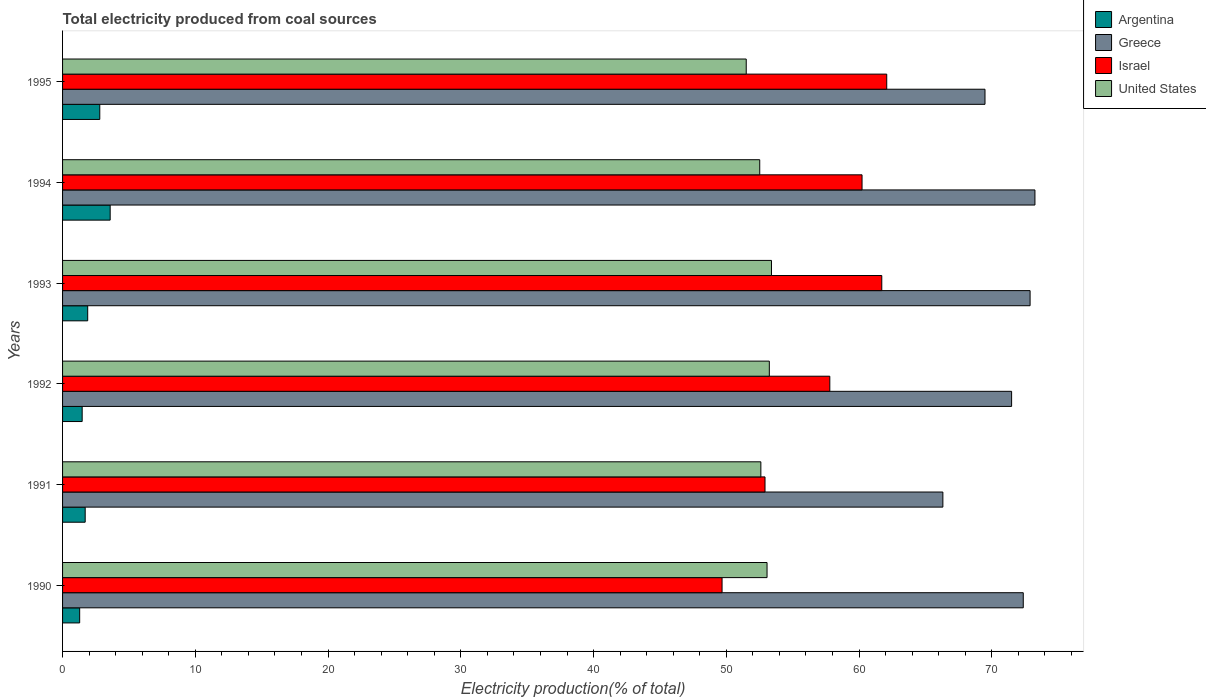How many different coloured bars are there?
Keep it short and to the point. 4. How many groups of bars are there?
Give a very brief answer. 6. Are the number of bars on each tick of the Y-axis equal?
Ensure brevity in your answer.  Yes. How many bars are there on the 2nd tick from the top?
Offer a very short reply. 4. What is the total electricity produced in United States in 1992?
Your response must be concise. 53.24. Across all years, what is the maximum total electricity produced in Argentina?
Make the answer very short. 3.59. Across all years, what is the minimum total electricity produced in United States?
Provide a succinct answer. 51.5. In which year was the total electricity produced in Israel maximum?
Keep it short and to the point. 1995. In which year was the total electricity produced in Israel minimum?
Provide a short and direct response. 1990. What is the total total electricity produced in Israel in the graph?
Give a very brief answer. 344.41. What is the difference between the total electricity produced in Israel in 1990 and that in 1992?
Offer a terse response. -8.12. What is the difference between the total electricity produced in United States in 1990 and the total electricity produced in Greece in 1992?
Ensure brevity in your answer.  -18.42. What is the average total electricity produced in Argentina per year?
Keep it short and to the point. 2.13. In the year 1993, what is the difference between the total electricity produced in Argentina and total electricity produced in Greece?
Keep it short and to the point. -70.99. What is the ratio of the total electricity produced in Argentina in 1990 to that in 1995?
Provide a succinct answer. 0.46. Is the total electricity produced in Argentina in 1992 less than that in 1995?
Keep it short and to the point. Yes. What is the difference between the highest and the second highest total electricity produced in Israel?
Offer a terse response. 0.37. What is the difference between the highest and the lowest total electricity produced in Argentina?
Keep it short and to the point. 2.3. Is the sum of the total electricity produced in United States in 1990 and 1991 greater than the maximum total electricity produced in Greece across all years?
Your response must be concise. Yes. What does the 4th bar from the top in 1991 represents?
Offer a very short reply. Argentina. What does the 1st bar from the bottom in 1991 represents?
Keep it short and to the point. Argentina. Is it the case that in every year, the sum of the total electricity produced in Argentina and total electricity produced in Israel is greater than the total electricity produced in Greece?
Provide a short and direct response. No. How many bars are there?
Offer a terse response. 24. Does the graph contain grids?
Provide a short and direct response. No. How many legend labels are there?
Your answer should be compact. 4. How are the legend labels stacked?
Make the answer very short. Vertical. What is the title of the graph?
Your answer should be compact. Total electricity produced from coal sources. Does "Panama" appear as one of the legend labels in the graph?
Your response must be concise. No. What is the Electricity production(% of total) of Argentina in 1990?
Give a very brief answer. 1.29. What is the Electricity production(% of total) of Greece in 1990?
Provide a succinct answer. 72.37. What is the Electricity production(% of total) in Israel in 1990?
Offer a very short reply. 49.68. What is the Electricity production(% of total) of United States in 1990?
Your answer should be very brief. 53.07. What is the Electricity production(% of total) in Argentina in 1991?
Keep it short and to the point. 1.7. What is the Electricity production(% of total) in Greece in 1991?
Offer a terse response. 66.31. What is the Electricity production(% of total) of Israel in 1991?
Ensure brevity in your answer.  52.91. What is the Electricity production(% of total) of United States in 1991?
Give a very brief answer. 52.6. What is the Electricity production(% of total) in Argentina in 1992?
Your response must be concise. 1.48. What is the Electricity production(% of total) in Greece in 1992?
Provide a succinct answer. 71.49. What is the Electricity production(% of total) in Israel in 1992?
Offer a very short reply. 57.8. What is the Electricity production(% of total) in United States in 1992?
Give a very brief answer. 53.24. What is the Electricity production(% of total) in Argentina in 1993?
Your answer should be compact. 1.89. What is the Electricity production(% of total) in Greece in 1993?
Provide a succinct answer. 72.88. What is the Electricity production(% of total) of Israel in 1993?
Give a very brief answer. 61.71. What is the Electricity production(% of total) in United States in 1993?
Ensure brevity in your answer.  53.4. What is the Electricity production(% of total) of Argentina in 1994?
Keep it short and to the point. 3.59. What is the Electricity production(% of total) in Greece in 1994?
Give a very brief answer. 73.25. What is the Electricity production(% of total) in Israel in 1994?
Offer a terse response. 60.22. What is the Electricity production(% of total) of United States in 1994?
Give a very brief answer. 52.52. What is the Electricity production(% of total) in Argentina in 1995?
Ensure brevity in your answer.  2.8. What is the Electricity production(% of total) of Greece in 1995?
Provide a succinct answer. 69.49. What is the Electricity production(% of total) of Israel in 1995?
Provide a succinct answer. 62.08. What is the Electricity production(% of total) in United States in 1995?
Keep it short and to the point. 51.5. Across all years, what is the maximum Electricity production(% of total) in Argentina?
Ensure brevity in your answer.  3.59. Across all years, what is the maximum Electricity production(% of total) of Greece?
Your answer should be compact. 73.25. Across all years, what is the maximum Electricity production(% of total) in Israel?
Offer a terse response. 62.08. Across all years, what is the maximum Electricity production(% of total) of United States?
Your response must be concise. 53.4. Across all years, what is the minimum Electricity production(% of total) in Argentina?
Your response must be concise. 1.29. Across all years, what is the minimum Electricity production(% of total) in Greece?
Your answer should be compact. 66.31. Across all years, what is the minimum Electricity production(% of total) in Israel?
Ensure brevity in your answer.  49.68. Across all years, what is the minimum Electricity production(% of total) of United States?
Your answer should be very brief. 51.5. What is the total Electricity production(% of total) in Argentina in the graph?
Give a very brief answer. 12.75. What is the total Electricity production(% of total) in Greece in the graph?
Provide a short and direct response. 425.79. What is the total Electricity production(% of total) of Israel in the graph?
Offer a terse response. 344.41. What is the total Electricity production(% of total) in United States in the graph?
Ensure brevity in your answer.  316.33. What is the difference between the Electricity production(% of total) of Argentina in 1990 and that in 1991?
Your response must be concise. -0.42. What is the difference between the Electricity production(% of total) in Greece in 1990 and that in 1991?
Provide a succinct answer. 6.06. What is the difference between the Electricity production(% of total) of Israel in 1990 and that in 1991?
Offer a very short reply. -3.23. What is the difference between the Electricity production(% of total) of United States in 1990 and that in 1991?
Your response must be concise. 0.47. What is the difference between the Electricity production(% of total) of Argentina in 1990 and that in 1992?
Provide a short and direct response. -0.19. What is the difference between the Electricity production(% of total) of Greece in 1990 and that in 1992?
Offer a very short reply. 0.88. What is the difference between the Electricity production(% of total) of Israel in 1990 and that in 1992?
Your answer should be compact. -8.12. What is the difference between the Electricity production(% of total) of United States in 1990 and that in 1992?
Offer a very short reply. -0.17. What is the difference between the Electricity production(% of total) in Argentina in 1990 and that in 1993?
Provide a short and direct response. -0.6. What is the difference between the Electricity production(% of total) of Greece in 1990 and that in 1993?
Your response must be concise. -0.51. What is the difference between the Electricity production(% of total) of Israel in 1990 and that in 1993?
Your response must be concise. -12.03. What is the difference between the Electricity production(% of total) in United States in 1990 and that in 1993?
Provide a short and direct response. -0.33. What is the difference between the Electricity production(% of total) of Argentina in 1990 and that in 1994?
Make the answer very short. -2.3. What is the difference between the Electricity production(% of total) of Greece in 1990 and that in 1994?
Provide a succinct answer. -0.88. What is the difference between the Electricity production(% of total) in Israel in 1990 and that in 1994?
Provide a succinct answer. -10.54. What is the difference between the Electricity production(% of total) in United States in 1990 and that in 1994?
Provide a succinct answer. 0.55. What is the difference between the Electricity production(% of total) in Argentina in 1990 and that in 1995?
Keep it short and to the point. -1.51. What is the difference between the Electricity production(% of total) in Greece in 1990 and that in 1995?
Provide a short and direct response. 2.88. What is the difference between the Electricity production(% of total) of Israel in 1990 and that in 1995?
Give a very brief answer. -12.4. What is the difference between the Electricity production(% of total) of United States in 1990 and that in 1995?
Your answer should be compact. 1.57. What is the difference between the Electricity production(% of total) of Argentina in 1991 and that in 1992?
Provide a short and direct response. 0.23. What is the difference between the Electricity production(% of total) of Greece in 1991 and that in 1992?
Your answer should be compact. -5.18. What is the difference between the Electricity production(% of total) of Israel in 1991 and that in 1992?
Offer a terse response. -4.88. What is the difference between the Electricity production(% of total) in United States in 1991 and that in 1992?
Give a very brief answer. -0.64. What is the difference between the Electricity production(% of total) in Argentina in 1991 and that in 1993?
Your answer should be very brief. -0.19. What is the difference between the Electricity production(% of total) of Greece in 1991 and that in 1993?
Provide a short and direct response. -6.57. What is the difference between the Electricity production(% of total) in Israel in 1991 and that in 1993?
Ensure brevity in your answer.  -8.8. What is the difference between the Electricity production(% of total) of United States in 1991 and that in 1993?
Offer a terse response. -0.8. What is the difference between the Electricity production(% of total) of Argentina in 1991 and that in 1994?
Offer a terse response. -1.88. What is the difference between the Electricity production(% of total) in Greece in 1991 and that in 1994?
Your response must be concise. -6.93. What is the difference between the Electricity production(% of total) of Israel in 1991 and that in 1994?
Your answer should be compact. -7.31. What is the difference between the Electricity production(% of total) of United States in 1991 and that in 1994?
Ensure brevity in your answer.  0.08. What is the difference between the Electricity production(% of total) in Argentina in 1991 and that in 1995?
Keep it short and to the point. -1.1. What is the difference between the Electricity production(% of total) in Greece in 1991 and that in 1995?
Offer a very short reply. -3.17. What is the difference between the Electricity production(% of total) in Israel in 1991 and that in 1995?
Offer a terse response. -9.17. What is the difference between the Electricity production(% of total) of United States in 1991 and that in 1995?
Your answer should be compact. 1.1. What is the difference between the Electricity production(% of total) of Argentina in 1992 and that in 1993?
Your response must be concise. -0.42. What is the difference between the Electricity production(% of total) in Greece in 1992 and that in 1993?
Make the answer very short. -1.39. What is the difference between the Electricity production(% of total) in Israel in 1992 and that in 1993?
Your answer should be very brief. -3.92. What is the difference between the Electricity production(% of total) in United States in 1992 and that in 1993?
Keep it short and to the point. -0.16. What is the difference between the Electricity production(% of total) of Argentina in 1992 and that in 1994?
Provide a succinct answer. -2.11. What is the difference between the Electricity production(% of total) of Greece in 1992 and that in 1994?
Keep it short and to the point. -1.76. What is the difference between the Electricity production(% of total) of Israel in 1992 and that in 1994?
Your answer should be very brief. -2.43. What is the difference between the Electricity production(% of total) in United States in 1992 and that in 1994?
Offer a terse response. 0.72. What is the difference between the Electricity production(% of total) of Argentina in 1992 and that in 1995?
Keep it short and to the point. -1.33. What is the difference between the Electricity production(% of total) in Greece in 1992 and that in 1995?
Ensure brevity in your answer.  2. What is the difference between the Electricity production(% of total) of Israel in 1992 and that in 1995?
Your response must be concise. -4.29. What is the difference between the Electricity production(% of total) in United States in 1992 and that in 1995?
Provide a short and direct response. 1.74. What is the difference between the Electricity production(% of total) of Argentina in 1993 and that in 1994?
Keep it short and to the point. -1.69. What is the difference between the Electricity production(% of total) in Greece in 1993 and that in 1994?
Provide a succinct answer. -0.37. What is the difference between the Electricity production(% of total) in Israel in 1993 and that in 1994?
Your response must be concise. 1.49. What is the difference between the Electricity production(% of total) of United States in 1993 and that in 1994?
Your answer should be very brief. 0.89. What is the difference between the Electricity production(% of total) of Argentina in 1993 and that in 1995?
Your answer should be compact. -0.91. What is the difference between the Electricity production(% of total) in Greece in 1993 and that in 1995?
Provide a succinct answer. 3.4. What is the difference between the Electricity production(% of total) of Israel in 1993 and that in 1995?
Make the answer very short. -0.37. What is the difference between the Electricity production(% of total) in United States in 1993 and that in 1995?
Keep it short and to the point. 1.9. What is the difference between the Electricity production(% of total) of Argentina in 1994 and that in 1995?
Provide a succinct answer. 0.78. What is the difference between the Electricity production(% of total) in Greece in 1994 and that in 1995?
Keep it short and to the point. 3.76. What is the difference between the Electricity production(% of total) of Israel in 1994 and that in 1995?
Give a very brief answer. -1.86. What is the difference between the Electricity production(% of total) of Argentina in 1990 and the Electricity production(% of total) of Greece in 1991?
Provide a succinct answer. -65.02. What is the difference between the Electricity production(% of total) in Argentina in 1990 and the Electricity production(% of total) in Israel in 1991?
Your answer should be very brief. -51.63. What is the difference between the Electricity production(% of total) in Argentina in 1990 and the Electricity production(% of total) in United States in 1991?
Your answer should be compact. -51.31. What is the difference between the Electricity production(% of total) of Greece in 1990 and the Electricity production(% of total) of Israel in 1991?
Make the answer very short. 19.45. What is the difference between the Electricity production(% of total) of Greece in 1990 and the Electricity production(% of total) of United States in 1991?
Your answer should be very brief. 19.77. What is the difference between the Electricity production(% of total) of Israel in 1990 and the Electricity production(% of total) of United States in 1991?
Give a very brief answer. -2.92. What is the difference between the Electricity production(% of total) in Argentina in 1990 and the Electricity production(% of total) in Greece in 1992?
Ensure brevity in your answer.  -70.2. What is the difference between the Electricity production(% of total) in Argentina in 1990 and the Electricity production(% of total) in Israel in 1992?
Your answer should be very brief. -56.51. What is the difference between the Electricity production(% of total) in Argentina in 1990 and the Electricity production(% of total) in United States in 1992?
Your answer should be compact. -51.95. What is the difference between the Electricity production(% of total) in Greece in 1990 and the Electricity production(% of total) in Israel in 1992?
Your answer should be compact. 14.57. What is the difference between the Electricity production(% of total) in Greece in 1990 and the Electricity production(% of total) in United States in 1992?
Offer a very short reply. 19.13. What is the difference between the Electricity production(% of total) in Israel in 1990 and the Electricity production(% of total) in United States in 1992?
Provide a succinct answer. -3.56. What is the difference between the Electricity production(% of total) in Argentina in 1990 and the Electricity production(% of total) in Greece in 1993?
Offer a terse response. -71.59. What is the difference between the Electricity production(% of total) in Argentina in 1990 and the Electricity production(% of total) in Israel in 1993?
Offer a terse response. -60.42. What is the difference between the Electricity production(% of total) of Argentina in 1990 and the Electricity production(% of total) of United States in 1993?
Ensure brevity in your answer.  -52.11. What is the difference between the Electricity production(% of total) of Greece in 1990 and the Electricity production(% of total) of Israel in 1993?
Your answer should be very brief. 10.66. What is the difference between the Electricity production(% of total) in Greece in 1990 and the Electricity production(% of total) in United States in 1993?
Make the answer very short. 18.97. What is the difference between the Electricity production(% of total) of Israel in 1990 and the Electricity production(% of total) of United States in 1993?
Offer a very short reply. -3.72. What is the difference between the Electricity production(% of total) of Argentina in 1990 and the Electricity production(% of total) of Greece in 1994?
Offer a terse response. -71.96. What is the difference between the Electricity production(% of total) in Argentina in 1990 and the Electricity production(% of total) in Israel in 1994?
Provide a succinct answer. -58.93. What is the difference between the Electricity production(% of total) of Argentina in 1990 and the Electricity production(% of total) of United States in 1994?
Provide a succinct answer. -51.23. What is the difference between the Electricity production(% of total) of Greece in 1990 and the Electricity production(% of total) of Israel in 1994?
Offer a terse response. 12.14. What is the difference between the Electricity production(% of total) in Greece in 1990 and the Electricity production(% of total) in United States in 1994?
Your answer should be compact. 19.85. What is the difference between the Electricity production(% of total) in Israel in 1990 and the Electricity production(% of total) in United States in 1994?
Ensure brevity in your answer.  -2.84. What is the difference between the Electricity production(% of total) in Argentina in 1990 and the Electricity production(% of total) in Greece in 1995?
Make the answer very short. -68.2. What is the difference between the Electricity production(% of total) of Argentina in 1990 and the Electricity production(% of total) of Israel in 1995?
Provide a short and direct response. -60.79. What is the difference between the Electricity production(% of total) in Argentina in 1990 and the Electricity production(% of total) in United States in 1995?
Keep it short and to the point. -50.21. What is the difference between the Electricity production(% of total) of Greece in 1990 and the Electricity production(% of total) of Israel in 1995?
Provide a succinct answer. 10.28. What is the difference between the Electricity production(% of total) of Greece in 1990 and the Electricity production(% of total) of United States in 1995?
Make the answer very short. 20.87. What is the difference between the Electricity production(% of total) in Israel in 1990 and the Electricity production(% of total) in United States in 1995?
Make the answer very short. -1.82. What is the difference between the Electricity production(% of total) of Argentina in 1991 and the Electricity production(% of total) of Greece in 1992?
Keep it short and to the point. -69.79. What is the difference between the Electricity production(% of total) of Argentina in 1991 and the Electricity production(% of total) of Israel in 1992?
Your answer should be very brief. -56.09. What is the difference between the Electricity production(% of total) of Argentina in 1991 and the Electricity production(% of total) of United States in 1992?
Offer a very short reply. -51.54. What is the difference between the Electricity production(% of total) of Greece in 1991 and the Electricity production(% of total) of Israel in 1992?
Your response must be concise. 8.52. What is the difference between the Electricity production(% of total) in Greece in 1991 and the Electricity production(% of total) in United States in 1992?
Provide a short and direct response. 13.07. What is the difference between the Electricity production(% of total) of Israel in 1991 and the Electricity production(% of total) of United States in 1992?
Provide a succinct answer. -0.33. What is the difference between the Electricity production(% of total) of Argentina in 1991 and the Electricity production(% of total) of Greece in 1993?
Your answer should be very brief. -71.18. What is the difference between the Electricity production(% of total) in Argentina in 1991 and the Electricity production(% of total) in Israel in 1993?
Ensure brevity in your answer.  -60.01. What is the difference between the Electricity production(% of total) in Argentina in 1991 and the Electricity production(% of total) in United States in 1993?
Offer a terse response. -51.7. What is the difference between the Electricity production(% of total) in Greece in 1991 and the Electricity production(% of total) in Israel in 1993?
Provide a short and direct response. 4.6. What is the difference between the Electricity production(% of total) in Greece in 1991 and the Electricity production(% of total) in United States in 1993?
Keep it short and to the point. 12.91. What is the difference between the Electricity production(% of total) of Israel in 1991 and the Electricity production(% of total) of United States in 1993?
Offer a very short reply. -0.49. What is the difference between the Electricity production(% of total) in Argentina in 1991 and the Electricity production(% of total) in Greece in 1994?
Your answer should be compact. -71.54. What is the difference between the Electricity production(% of total) of Argentina in 1991 and the Electricity production(% of total) of Israel in 1994?
Make the answer very short. -58.52. What is the difference between the Electricity production(% of total) in Argentina in 1991 and the Electricity production(% of total) in United States in 1994?
Your response must be concise. -50.81. What is the difference between the Electricity production(% of total) of Greece in 1991 and the Electricity production(% of total) of Israel in 1994?
Make the answer very short. 6.09. What is the difference between the Electricity production(% of total) of Greece in 1991 and the Electricity production(% of total) of United States in 1994?
Your answer should be compact. 13.8. What is the difference between the Electricity production(% of total) in Israel in 1991 and the Electricity production(% of total) in United States in 1994?
Make the answer very short. 0.4. What is the difference between the Electricity production(% of total) in Argentina in 1991 and the Electricity production(% of total) in Greece in 1995?
Make the answer very short. -67.78. What is the difference between the Electricity production(% of total) of Argentina in 1991 and the Electricity production(% of total) of Israel in 1995?
Offer a terse response. -60.38. What is the difference between the Electricity production(% of total) in Argentina in 1991 and the Electricity production(% of total) in United States in 1995?
Your response must be concise. -49.79. What is the difference between the Electricity production(% of total) of Greece in 1991 and the Electricity production(% of total) of Israel in 1995?
Ensure brevity in your answer.  4.23. What is the difference between the Electricity production(% of total) in Greece in 1991 and the Electricity production(% of total) in United States in 1995?
Make the answer very short. 14.81. What is the difference between the Electricity production(% of total) in Israel in 1991 and the Electricity production(% of total) in United States in 1995?
Your response must be concise. 1.42. What is the difference between the Electricity production(% of total) of Argentina in 1992 and the Electricity production(% of total) of Greece in 1993?
Provide a short and direct response. -71.41. What is the difference between the Electricity production(% of total) in Argentina in 1992 and the Electricity production(% of total) in Israel in 1993?
Ensure brevity in your answer.  -60.23. What is the difference between the Electricity production(% of total) of Argentina in 1992 and the Electricity production(% of total) of United States in 1993?
Give a very brief answer. -51.92. What is the difference between the Electricity production(% of total) in Greece in 1992 and the Electricity production(% of total) in Israel in 1993?
Give a very brief answer. 9.78. What is the difference between the Electricity production(% of total) of Greece in 1992 and the Electricity production(% of total) of United States in 1993?
Your answer should be very brief. 18.09. What is the difference between the Electricity production(% of total) of Israel in 1992 and the Electricity production(% of total) of United States in 1993?
Provide a short and direct response. 4.39. What is the difference between the Electricity production(% of total) in Argentina in 1992 and the Electricity production(% of total) in Greece in 1994?
Offer a terse response. -71.77. What is the difference between the Electricity production(% of total) in Argentina in 1992 and the Electricity production(% of total) in Israel in 1994?
Your response must be concise. -58.75. What is the difference between the Electricity production(% of total) in Argentina in 1992 and the Electricity production(% of total) in United States in 1994?
Make the answer very short. -51.04. What is the difference between the Electricity production(% of total) in Greece in 1992 and the Electricity production(% of total) in Israel in 1994?
Keep it short and to the point. 11.27. What is the difference between the Electricity production(% of total) of Greece in 1992 and the Electricity production(% of total) of United States in 1994?
Your response must be concise. 18.97. What is the difference between the Electricity production(% of total) in Israel in 1992 and the Electricity production(% of total) in United States in 1994?
Your answer should be compact. 5.28. What is the difference between the Electricity production(% of total) in Argentina in 1992 and the Electricity production(% of total) in Greece in 1995?
Offer a very short reply. -68.01. What is the difference between the Electricity production(% of total) of Argentina in 1992 and the Electricity production(% of total) of Israel in 1995?
Offer a terse response. -60.61. What is the difference between the Electricity production(% of total) of Argentina in 1992 and the Electricity production(% of total) of United States in 1995?
Make the answer very short. -50.02. What is the difference between the Electricity production(% of total) of Greece in 1992 and the Electricity production(% of total) of Israel in 1995?
Offer a terse response. 9.41. What is the difference between the Electricity production(% of total) of Greece in 1992 and the Electricity production(% of total) of United States in 1995?
Give a very brief answer. 19.99. What is the difference between the Electricity production(% of total) of Israel in 1992 and the Electricity production(% of total) of United States in 1995?
Your answer should be compact. 6.3. What is the difference between the Electricity production(% of total) in Argentina in 1993 and the Electricity production(% of total) in Greece in 1994?
Offer a very short reply. -71.35. What is the difference between the Electricity production(% of total) of Argentina in 1993 and the Electricity production(% of total) of Israel in 1994?
Offer a terse response. -58.33. What is the difference between the Electricity production(% of total) in Argentina in 1993 and the Electricity production(% of total) in United States in 1994?
Your answer should be compact. -50.62. What is the difference between the Electricity production(% of total) in Greece in 1993 and the Electricity production(% of total) in Israel in 1994?
Your answer should be compact. 12.66. What is the difference between the Electricity production(% of total) in Greece in 1993 and the Electricity production(% of total) in United States in 1994?
Provide a succinct answer. 20.37. What is the difference between the Electricity production(% of total) in Israel in 1993 and the Electricity production(% of total) in United States in 1994?
Provide a succinct answer. 9.19. What is the difference between the Electricity production(% of total) of Argentina in 1993 and the Electricity production(% of total) of Greece in 1995?
Provide a short and direct response. -67.59. What is the difference between the Electricity production(% of total) in Argentina in 1993 and the Electricity production(% of total) in Israel in 1995?
Give a very brief answer. -60.19. What is the difference between the Electricity production(% of total) in Argentina in 1993 and the Electricity production(% of total) in United States in 1995?
Provide a succinct answer. -49.61. What is the difference between the Electricity production(% of total) of Greece in 1993 and the Electricity production(% of total) of Israel in 1995?
Give a very brief answer. 10.8. What is the difference between the Electricity production(% of total) of Greece in 1993 and the Electricity production(% of total) of United States in 1995?
Make the answer very short. 21.38. What is the difference between the Electricity production(% of total) of Israel in 1993 and the Electricity production(% of total) of United States in 1995?
Provide a succinct answer. 10.21. What is the difference between the Electricity production(% of total) in Argentina in 1994 and the Electricity production(% of total) in Greece in 1995?
Offer a terse response. -65.9. What is the difference between the Electricity production(% of total) of Argentina in 1994 and the Electricity production(% of total) of Israel in 1995?
Ensure brevity in your answer.  -58.5. What is the difference between the Electricity production(% of total) of Argentina in 1994 and the Electricity production(% of total) of United States in 1995?
Provide a short and direct response. -47.91. What is the difference between the Electricity production(% of total) in Greece in 1994 and the Electricity production(% of total) in Israel in 1995?
Your answer should be very brief. 11.16. What is the difference between the Electricity production(% of total) of Greece in 1994 and the Electricity production(% of total) of United States in 1995?
Give a very brief answer. 21.75. What is the difference between the Electricity production(% of total) in Israel in 1994 and the Electricity production(% of total) in United States in 1995?
Keep it short and to the point. 8.72. What is the average Electricity production(% of total) of Argentina per year?
Provide a succinct answer. 2.13. What is the average Electricity production(% of total) of Greece per year?
Your answer should be compact. 70.96. What is the average Electricity production(% of total) of Israel per year?
Your answer should be compact. 57.4. What is the average Electricity production(% of total) of United States per year?
Keep it short and to the point. 52.72. In the year 1990, what is the difference between the Electricity production(% of total) in Argentina and Electricity production(% of total) in Greece?
Give a very brief answer. -71.08. In the year 1990, what is the difference between the Electricity production(% of total) of Argentina and Electricity production(% of total) of Israel?
Your answer should be very brief. -48.39. In the year 1990, what is the difference between the Electricity production(% of total) of Argentina and Electricity production(% of total) of United States?
Give a very brief answer. -51.78. In the year 1990, what is the difference between the Electricity production(% of total) of Greece and Electricity production(% of total) of Israel?
Offer a very short reply. 22.69. In the year 1990, what is the difference between the Electricity production(% of total) in Greece and Electricity production(% of total) in United States?
Make the answer very short. 19.3. In the year 1990, what is the difference between the Electricity production(% of total) of Israel and Electricity production(% of total) of United States?
Make the answer very short. -3.39. In the year 1991, what is the difference between the Electricity production(% of total) in Argentina and Electricity production(% of total) in Greece?
Provide a short and direct response. -64.61. In the year 1991, what is the difference between the Electricity production(% of total) in Argentina and Electricity production(% of total) in Israel?
Provide a short and direct response. -51.21. In the year 1991, what is the difference between the Electricity production(% of total) of Argentina and Electricity production(% of total) of United States?
Your response must be concise. -50.9. In the year 1991, what is the difference between the Electricity production(% of total) of Greece and Electricity production(% of total) of Israel?
Provide a succinct answer. 13.4. In the year 1991, what is the difference between the Electricity production(% of total) in Greece and Electricity production(% of total) in United States?
Your answer should be compact. 13.71. In the year 1991, what is the difference between the Electricity production(% of total) in Israel and Electricity production(% of total) in United States?
Provide a succinct answer. 0.31. In the year 1992, what is the difference between the Electricity production(% of total) of Argentina and Electricity production(% of total) of Greece?
Provide a succinct answer. -70.01. In the year 1992, what is the difference between the Electricity production(% of total) of Argentina and Electricity production(% of total) of Israel?
Provide a short and direct response. -56.32. In the year 1992, what is the difference between the Electricity production(% of total) in Argentina and Electricity production(% of total) in United States?
Provide a succinct answer. -51.76. In the year 1992, what is the difference between the Electricity production(% of total) of Greece and Electricity production(% of total) of Israel?
Offer a terse response. 13.69. In the year 1992, what is the difference between the Electricity production(% of total) in Greece and Electricity production(% of total) in United States?
Your answer should be very brief. 18.25. In the year 1992, what is the difference between the Electricity production(% of total) of Israel and Electricity production(% of total) of United States?
Your response must be concise. 4.56. In the year 1993, what is the difference between the Electricity production(% of total) of Argentina and Electricity production(% of total) of Greece?
Offer a terse response. -70.99. In the year 1993, what is the difference between the Electricity production(% of total) in Argentina and Electricity production(% of total) in Israel?
Give a very brief answer. -59.82. In the year 1993, what is the difference between the Electricity production(% of total) in Argentina and Electricity production(% of total) in United States?
Provide a short and direct response. -51.51. In the year 1993, what is the difference between the Electricity production(% of total) in Greece and Electricity production(% of total) in Israel?
Your answer should be very brief. 11.17. In the year 1993, what is the difference between the Electricity production(% of total) of Greece and Electricity production(% of total) of United States?
Your answer should be very brief. 19.48. In the year 1993, what is the difference between the Electricity production(% of total) of Israel and Electricity production(% of total) of United States?
Keep it short and to the point. 8.31. In the year 1994, what is the difference between the Electricity production(% of total) in Argentina and Electricity production(% of total) in Greece?
Ensure brevity in your answer.  -69.66. In the year 1994, what is the difference between the Electricity production(% of total) in Argentina and Electricity production(% of total) in Israel?
Your answer should be very brief. -56.64. In the year 1994, what is the difference between the Electricity production(% of total) in Argentina and Electricity production(% of total) in United States?
Your response must be concise. -48.93. In the year 1994, what is the difference between the Electricity production(% of total) of Greece and Electricity production(% of total) of Israel?
Give a very brief answer. 13.02. In the year 1994, what is the difference between the Electricity production(% of total) of Greece and Electricity production(% of total) of United States?
Make the answer very short. 20.73. In the year 1994, what is the difference between the Electricity production(% of total) of Israel and Electricity production(% of total) of United States?
Give a very brief answer. 7.71. In the year 1995, what is the difference between the Electricity production(% of total) of Argentina and Electricity production(% of total) of Greece?
Provide a succinct answer. -66.68. In the year 1995, what is the difference between the Electricity production(% of total) of Argentina and Electricity production(% of total) of Israel?
Your answer should be compact. -59.28. In the year 1995, what is the difference between the Electricity production(% of total) in Argentina and Electricity production(% of total) in United States?
Offer a terse response. -48.7. In the year 1995, what is the difference between the Electricity production(% of total) in Greece and Electricity production(% of total) in Israel?
Give a very brief answer. 7.4. In the year 1995, what is the difference between the Electricity production(% of total) of Greece and Electricity production(% of total) of United States?
Make the answer very short. 17.99. In the year 1995, what is the difference between the Electricity production(% of total) of Israel and Electricity production(% of total) of United States?
Make the answer very short. 10.58. What is the ratio of the Electricity production(% of total) in Argentina in 1990 to that in 1991?
Give a very brief answer. 0.76. What is the ratio of the Electricity production(% of total) of Greece in 1990 to that in 1991?
Ensure brevity in your answer.  1.09. What is the ratio of the Electricity production(% of total) in Israel in 1990 to that in 1991?
Your answer should be very brief. 0.94. What is the ratio of the Electricity production(% of total) in United States in 1990 to that in 1991?
Your response must be concise. 1.01. What is the ratio of the Electricity production(% of total) of Argentina in 1990 to that in 1992?
Provide a succinct answer. 0.87. What is the ratio of the Electricity production(% of total) in Greece in 1990 to that in 1992?
Your answer should be very brief. 1.01. What is the ratio of the Electricity production(% of total) in Israel in 1990 to that in 1992?
Your answer should be compact. 0.86. What is the ratio of the Electricity production(% of total) in Argentina in 1990 to that in 1993?
Your response must be concise. 0.68. What is the ratio of the Electricity production(% of total) of Greece in 1990 to that in 1993?
Offer a very short reply. 0.99. What is the ratio of the Electricity production(% of total) in Israel in 1990 to that in 1993?
Ensure brevity in your answer.  0.81. What is the ratio of the Electricity production(% of total) of Argentina in 1990 to that in 1994?
Ensure brevity in your answer.  0.36. What is the ratio of the Electricity production(% of total) in Greece in 1990 to that in 1994?
Your answer should be very brief. 0.99. What is the ratio of the Electricity production(% of total) in Israel in 1990 to that in 1994?
Your response must be concise. 0.82. What is the ratio of the Electricity production(% of total) in United States in 1990 to that in 1994?
Ensure brevity in your answer.  1.01. What is the ratio of the Electricity production(% of total) in Argentina in 1990 to that in 1995?
Offer a terse response. 0.46. What is the ratio of the Electricity production(% of total) in Greece in 1990 to that in 1995?
Provide a succinct answer. 1.04. What is the ratio of the Electricity production(% of total) of Israel in 1990 to that in 1995?
Ensure brevity in your answer.  0.8. What is the ratio of the Electricity production(% of total) in United States in 1990 to that in 1995?
Your answer should be very brief. 1.03. What is the ratio of the Electricity production(% of total) of Argentina in 1991 to that in 1992?
Offer a terse response. 1.15. What is the ratio of the Electricity production(% of total) in Greece in 1991 to that in 1992?
Make the answer very short. 0.93. What is the ratio of the Electricity production(% of total) in Israel in 1991 to that in 1992?
Your response must be concise. 0.92. What is the ratio of the Electricity production(% of total) in Argentina in 1991 to that in 1993?
Offer a very short reply. 0.9. What is the ratio of the Electricity production(% of total) of Greece in 1991 to that in 1993?
Your answer should be very brief. 0.91. What is the ratio of the Electricity production(% of total) of Israel in 1991 to that in 1993?
Offer a very short reply. 0.86. What is the ratio of the Electricity production(% of total) of United States in 1991 to that in 1993?
Your answer should be compact. 0.98. What is the ratio of the Electricity production(% of total) in Argentina in 1991 to that in 1994?
Keep it short and to the point. 0.48. What is the ratio of the Electricity production(% of total) in Greece in 1991 to that in 1994?
Your response must be concise. 0.91. What is the ratio of the Electricity production(% of total) of Israel in 1991 to that in 1994?
Offer a terse response. 0.88. What is the ratio of the Electricity production(% of total) of United States in 1991 to that in 1994?
Offer a terse response. 1. What is the ratio of the Electricity production(% of total) of Argentina in 1991 to that in 1995?
Provide a short and direct response. 0.61. What is the ratio of the Electricity production(% of total) in Greece in 1991 to that in 1995?
Offer a very short reply. 0.95. What is the ratio of the Electricity production(% of total) in Israel in 1991 to that in 1995?
Your answer should be compact. 0.85. What is the ratio of the Electricity production(% of total) of United States in 1991 to that in 1995?
Make the answer very short. 1.02. What is the ratio of the Electricity production(% of total) in Argentina in 1992 to that in 1993?
Provide a succinct answer. 0.78. What is the ratio of the Electricity production(% of total) in Greece in 1992 to that in 1993?
Give a very brief answer. 0.98. What is the ratio of the Electricity production(% of total) in Israel in 1992 to that in 1993?
Make the answer very short. 0.94. What is the ratio of the Electricity production(% of total) of United States in 1992 to that in 1993?
Provide a short and direct response. 1. What is the ratio of the Electricity production(% of total) of Argentina in 1992 to that in 1994?
Give a very brief answer. 0.41. What is the ratio of the Electricity production(% of total) of Israel in 1992 to that in 1994?
Keep it short and to the point. 0.96. What is the ratio of the Electricity production(% of total) of United States in 1992 to that in 1994?
Keep it short and to the point. 1.01. What is the ratio of the Electricity production(% of total) in Argentina in 1992 to that in 1995?
Offer a very short reply. 0.53. What is the ratio of the Electricity production(% of total) in Greece in 1992 to that in 1995?
Your answer should be very brief. 1.03. What is the ratio of the Electricity production(% of total) in Israel in 1992 to that in 1995?
Keep it short and to the point. 0.93. What is the ratio of the Electricity production(% of total) of United States in 1992 to that in 1995?
Give a very brief answer. 1.03. What is the ratio of the Electricity production(% of total) of Argentina in 1993 to that in 1994?
Your answer should be very brief. 0.53. What is the ratio of the Electricity production(% of total) in Greece in 1993 to that in 1994?
Keep it short and to the point. 0.99. What is the ratio of the Electricity production(% of total) in Israel in 1993 to that in 1994?
Make the answer very short. 1.02. What is the ratio of the Electricity production(% of total) of United States in 1993 to that in 1994?
Your response must be concise. 1.02. What is the ratio of the Electricity production(% of total) of Argentina in 1993 to that in 1995?
Your answer should be very brief. 0.68. What is the ratio of the Electricity production(% of total) of Greece in 1993 to that in 1995?
Make the answer very short. 1.05. What is the ratio of the Electricity production(% of total) of United States in 1993 to that in 1995?
Give a very brief answer. 1.04. What is the ratio of the Electricity production(% of total) of Argentina in 1994 to that in 1995?
Keep it short and to the point. 1.28. What is the ratio of the Electricity production(% of total) of Greece in 1994 to that in 1995?
Your response must be concise. 1.05. What is the ratio of the Electricity production(% of total) in United States in 1994 to that in 1995?
Your response must be concise. 1.02. What is the difference between the highest and the second highest Electricity production(% of total) of Argentina?
Make the answer very short. 0.78. What is the difference between the highest and the second highest Electricity production(% of total) in Greece?
Your response must be concise. 0.37. What is the difference between the highest and the second highest Electricity production(% of total) in Israel?
Offer a very short reply. 0.37. What is the difference between the highest and the second highest Electricity production(% of total) in United States?
Offer a terse response. 0.16. What is the difference between the highest and the lowest Electricity production(% of total) in Argentina?
Offer a terse response. 2.3. What is the difference between the highest and the lowest Electricity production(% of total) in Greece?
Ensure brevity in your answer.  6.93. What is the difference between the highest and the lowest Electricity production(% of total) of Israel?
Offer a very short reply. 12.4. What is the difference between the highest and the lowest Electricity production(% of total) in United States?
Give a very brief answer. 1.9. 